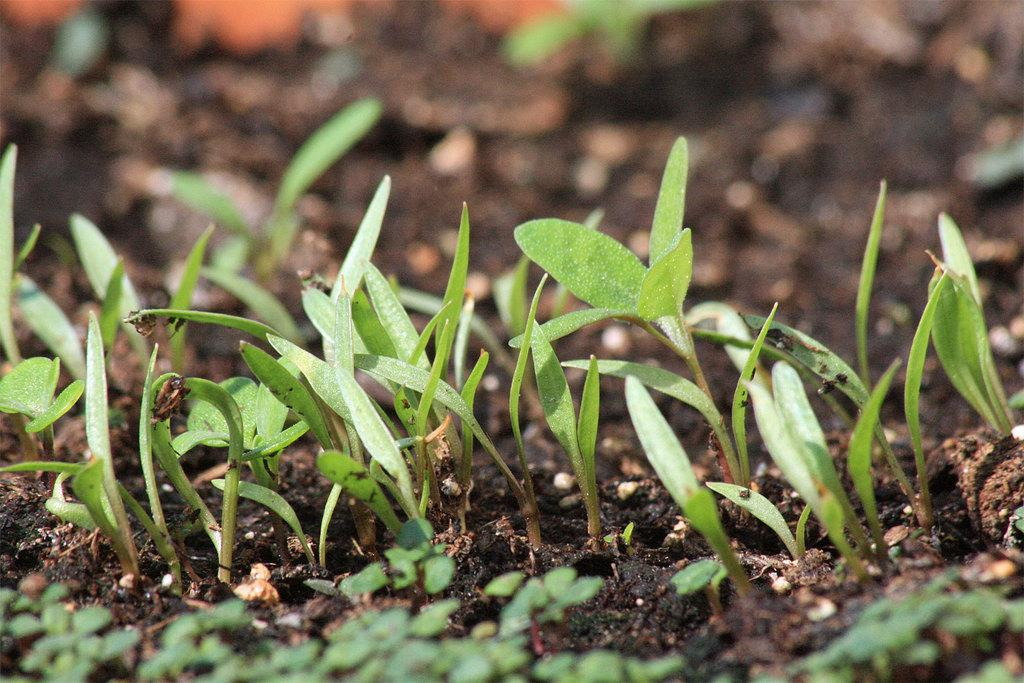What type of soil is visible in the image? There is black soil in the image. What else can be seen in the image besides the soil? There are plants in the image. What type of behavior is being discussed in the lunchroom in the image? There is no lunchroom or discussion of behavior present in the image; it features black soil and plants. 